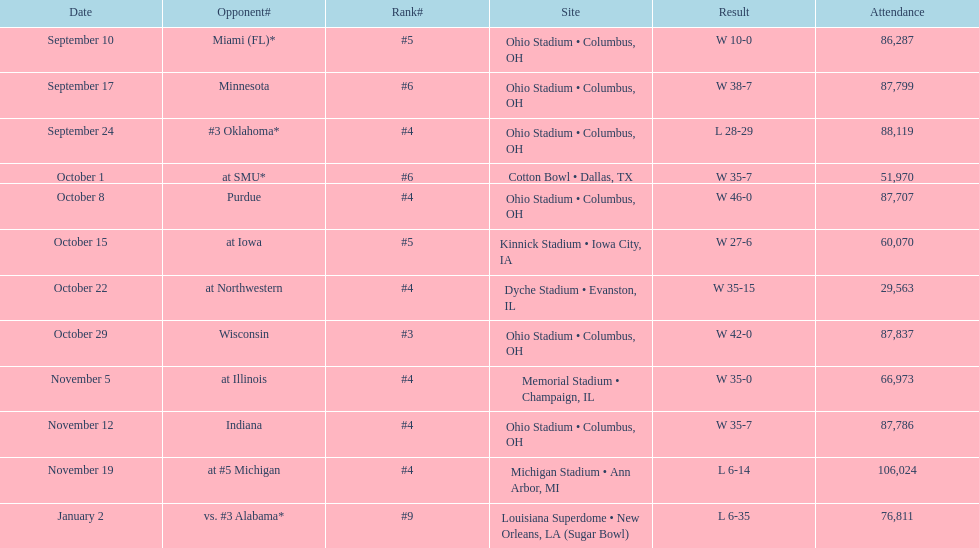What was the total number of victories for this team in the current season? 9. 